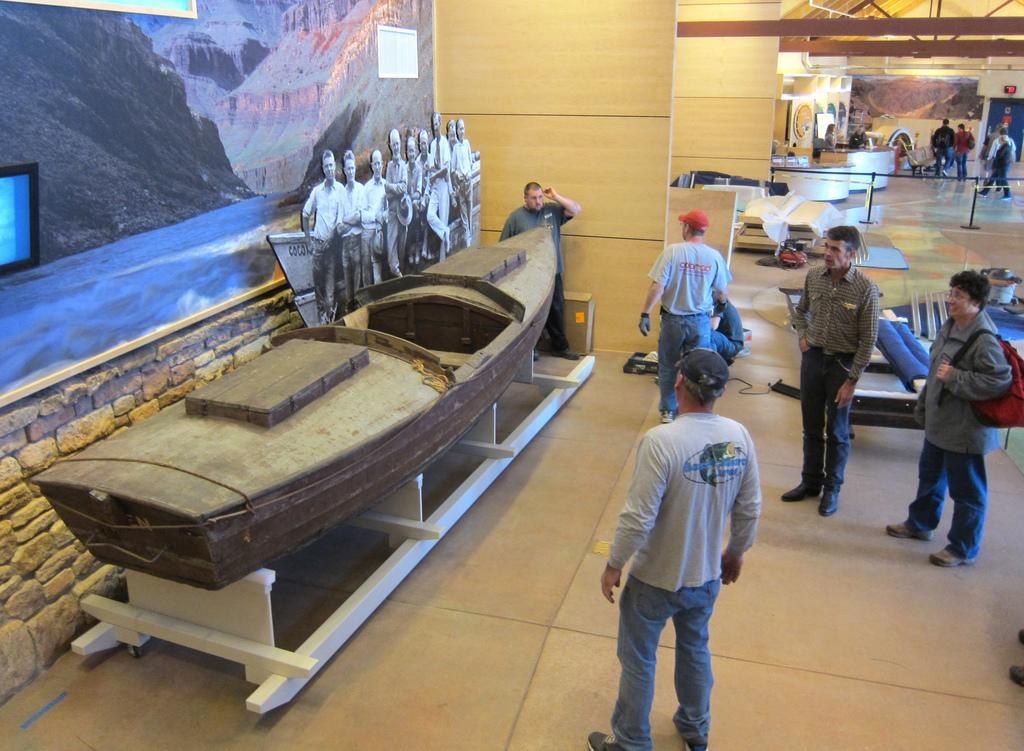In one or two sentences, can you explain what this image depicts? This picture is taken inside the room. In this image, on the right side, we can see a group of people. On the left side, we can see a boat and a man. On the left side, we can also see a black and white photo. On the left side, we can also see a photo frame which is attached to a wall. In the background, we can see a group of people. 